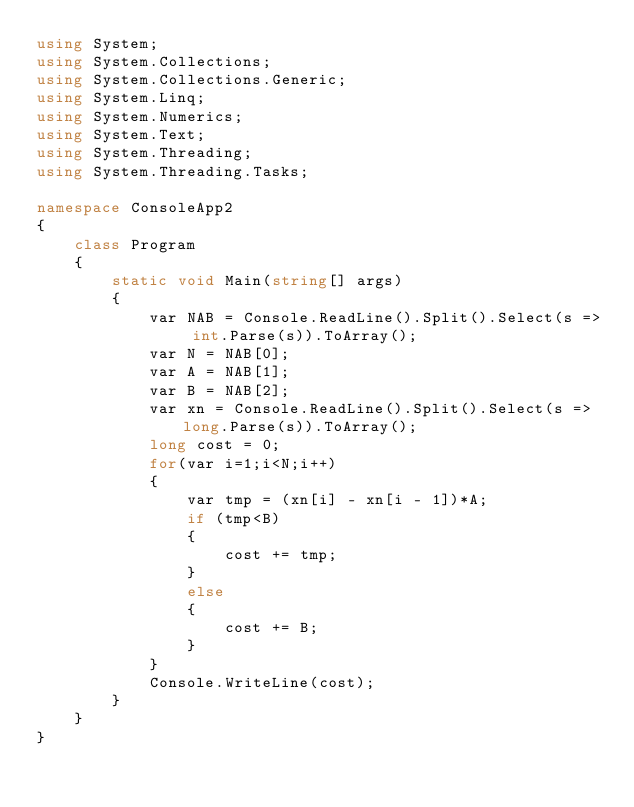Convert code to text. <code><loc_0><loc_0><loc_500><loc_500><_C#_>using System;
using System.Collections;
using System.Collections.Generic;
using System.Linq;
using System.Numerics;
using System.Text;
using System.Threading;
using System.Threading.Tasks;

namespace ConsoleApp2
{
    class Program
    {
        static void Main(string[] args)
        {
            var NAB = Console.ReadLine().Split().Select(s => int.Parse(s)).ToArray();
            var N = NAB[0];
            var A = NAB[1];
            var B = NAB[2];
            var xn = Console.ReadLine().Split().Select(s => long.Parse(s)).ToArray();
            long cost = 0;
            for(var i=1;i<N;i++)
            {
                var tmp = (xn[i] - xn[i - 1])*A;
                if (tmp<B)
                {
                    cost += tmp;
                }
                else
                {
                    cost += B;
                }
            }
            Console.WriteLine(cost);
        }
    }
}</code> 